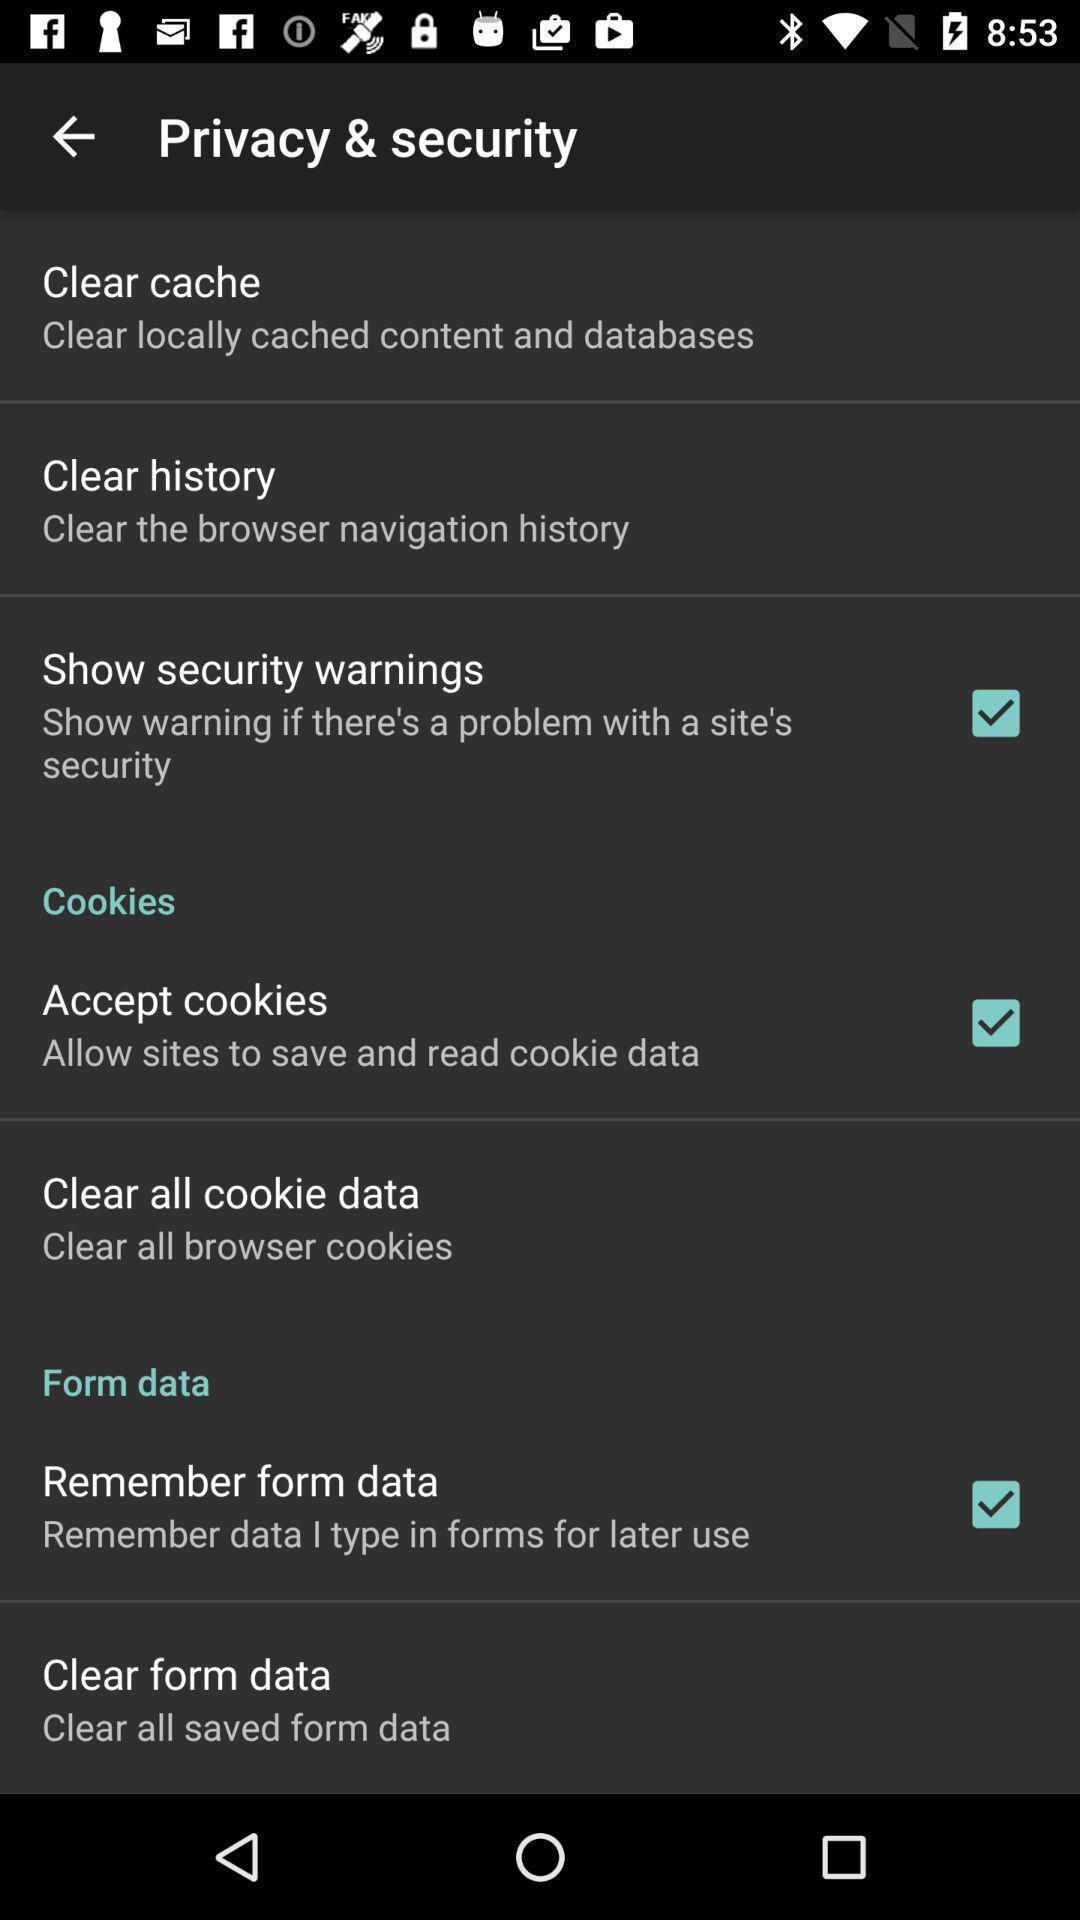What is the overall content of this screenshot? Social app showing privacy and security. 